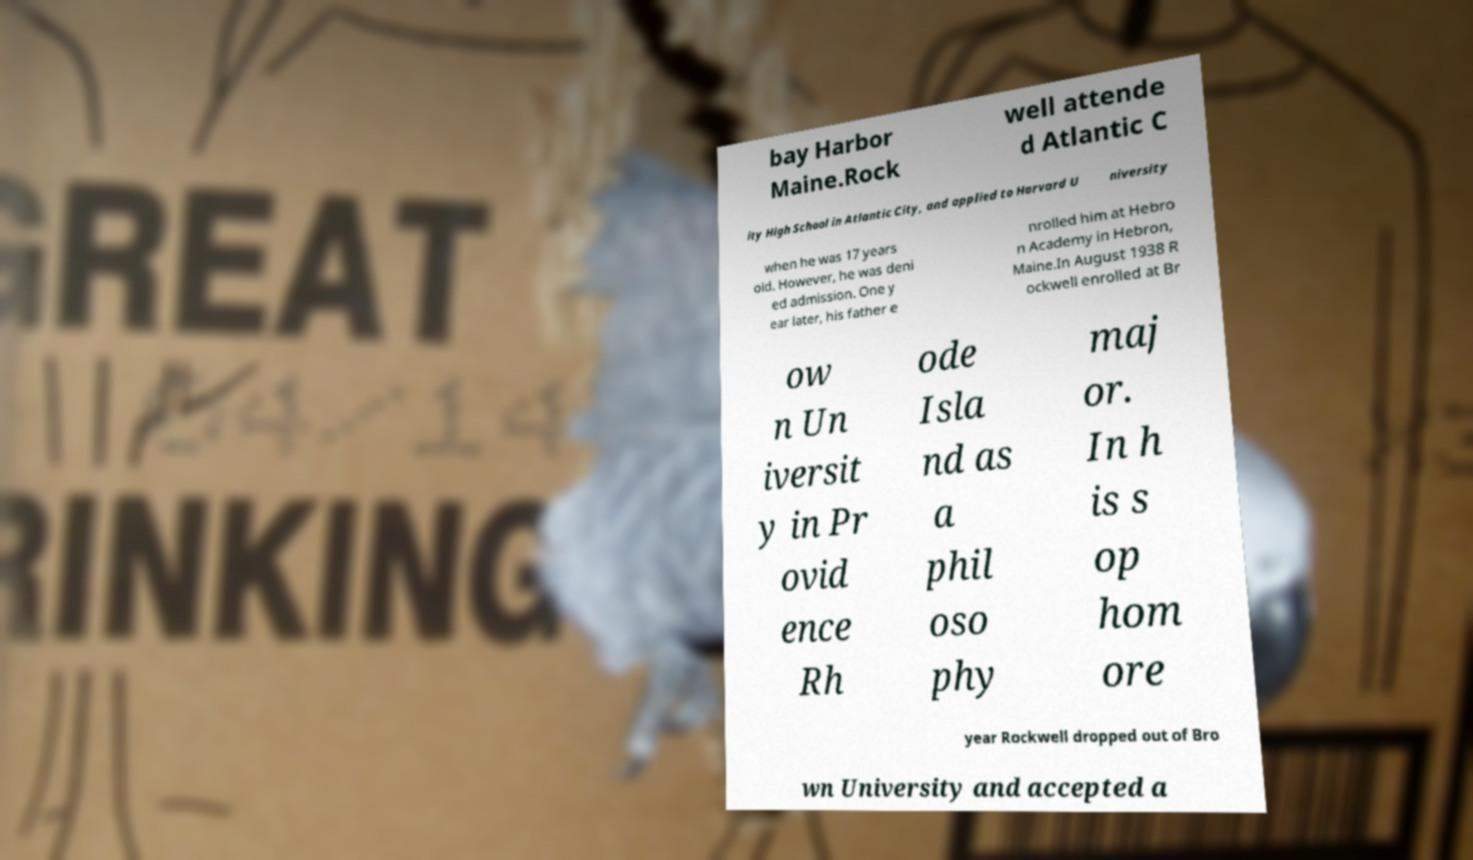Can you read and provide the text displayed in the image?This photo seems to have some interesting text. Can you extract and type it out for me? bay Harbor Maine.Rock well attende d Atlantic C ity High School in Atlantic City, and applied to Harvard U niversity when he was 17 years old. However, he was deni ed admission. One y ear later, his father e nrolled him at Hebro n Academy in Hebron, Maine.In August 1938 R ockwell enrolled at Br ow n Un iversit y in Pr ovid ence Rh ode Isla nd as a phil oso phy maj or. In h is s op hom ore year Rockwell dropped out of Bro wn University and accepted a 